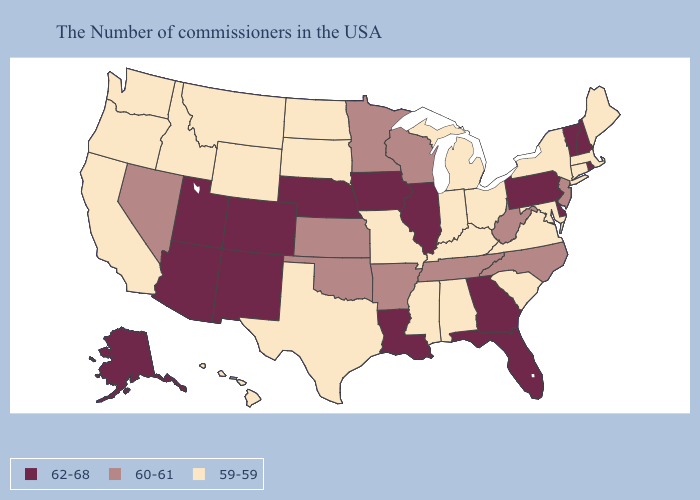Does the first symbol in the legend represent the smallest category?
Give a very brief answer. No. Name the states that have a value in the range 62-68?
Short answer required. Rhode Island, New Hampshire, Vermont, Delaware, Pennsylvania, Florida, Georgia, Illinois, Louisiana, Iowa, Nebraska, Colorado, New Mexico, Utah, Arizona, Alaska. Does Nebraska have the highest value in the MidWest?
Quick response, please. Yes. Which states hav the highest value in the Northeast?
Concise answer only. Rhode Island, New Hampshire, Vermont, Pennsylvania. What is the highest value in states that border Nebraska?
Quick response, please. 62-68. How many symbols are there in the legend?
Answer briefly. 3. What is the value of Delaware?
Quick response, please. 62-68. What is the lowest value in the MidWest?
Be succinct. 59-59. What is the lowest value in the MidWest?
Quick response, please. 59-59. Name the states that have a value in the range 60-61?
Write a very short answer. New Jersey, North Carolina, West Virginia, Tennessee, Wisconsin, Arkansas, Minnesota, Kansas, Oklahoma, Nevada. Which states hav the highest value in the South?
Quick response, please. Delaware, Florida, Georgia, Louisiana. Does Georgia have a higher value than Mississippi?
Short answer required. Yes. How many symbols are there in the legend?
Be succinct. 3. What is the value of South Dakota?
Be succinct. 59-59. Does the first symbol in the legend represent the smallest category?
Answer briefly. No. 